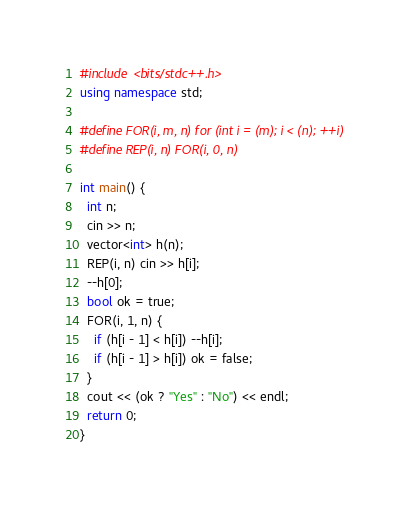<code> <loc_0><loc_0><loc_500><loc_500><_C++_>#include <bits/stdc++.h>
using namespace std;

#define FOR(i, m, n) for (int i = (m); i < (n); ++i)
#define REP(i, n) FOR(i, 0, n)

int main() {
  int n;
  cin >> n;
  vector<int> h(n);
  REP(i, n) cin >> h[i];
  --h[0];
  bool ok = true;
  FOR(i, 1, n) {
    if (h[i - 1] < h[i]) --h[i];
    if (h[i - 1] > h[i]) ok = false;
  }
  cout << (ok ? "Yes" : "No") << endl;
  return 0;
}
</code> 